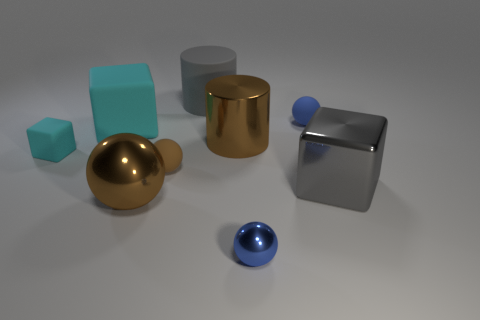There is a large rubber cylinder; does it have the same color as the small thing that is on the left side of the brown matte object?
Make the answer very short. No. There is a gray object that is behind the tiny matte thing that is left of the brown sphere behind the big gray metal thing; what size is it?
Your answer should be compact. Large. How many large cubes are the same color as the small rubber cube?
Keep it short and to the point. 1. How many objects are blue objects or small balls that are on the right side of the brown matte object?
Keep it short and to the point. 2. The tiny metallic sphere has what color?
Provide a short and direct response. Blue. There is a cube that is on the right side of the tiny blue metallic object; what is its color?
Give a very brief answer. Gray. There is a matte sphere behind the tiny cyan matte block; how many tiny objects are to the left of it?
Your response must be concise. 3. Do the brown metal cylinder and the brown sphere that is in front of the small brown matte object have the same size?
Make the answer very short. Yes. Are there any green balls that have the same size as the brown metal ball?
Provide a short and direct response. No. What number of objects are either big matte cylinders or small cyan rubber cubes?
Provide a short and direct response. 2. 